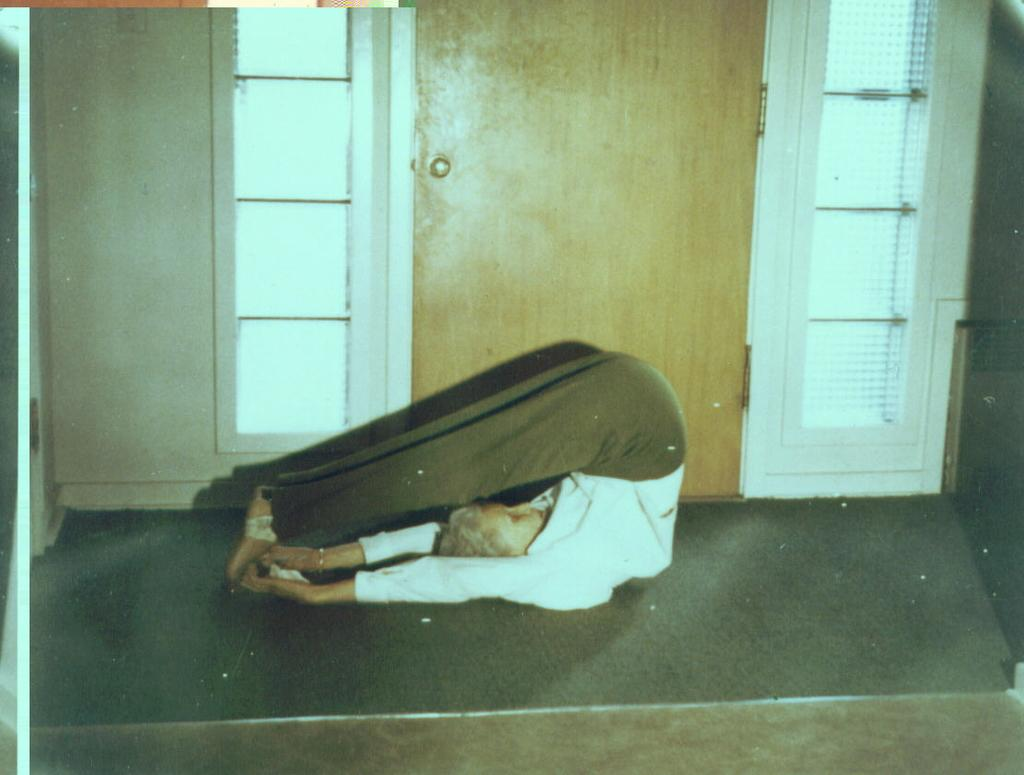What is the person in the image doing? The person in the image is performing yoga. What can be seen behind the person? There is a door and two windows behind the person. What type of drum is the person playing in the image? There is no drum present in the image; the person is performing yoga. 